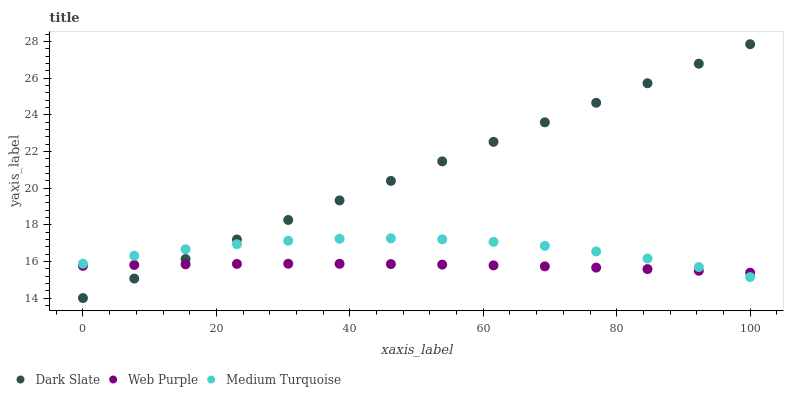Does Web Purple have the minimum area under the curve?
Answer yes or no. Yes. Does Dark Slate have the maximum area under the curve?
Answer yes or no. Yes. Does Medium Turquoise have the minimum area under the curve?
Answer yes or no. No. Does Medium Turquoise have the maximum area under the curve?
Answer yes or no. No. Is Dark Slate the smoothest?
Answer yes or no. Yes. Is Medium Turquoise the roughest?
Answer yes or no. Yes. Is Web Purple the smoothest?
Answer yes or no. No. Is Web Purple the roughest?
Answer yes or no. No. Does Dark Slate have the lowest value?
Answer yes or no. Yes. Does Medium Turquoise have the lowest value?
Answer yes or no. No. Does Dark Slate have the highest value?
Answer yes or no. Yes. Does Medium Turquoise have the highest value?
Answer yes or no. No. Does Medium Turquoise intersect Dark Slate?
Answer yes or no. Yes. Is Medium Turquoise less than Dark Slate?
Answer yes or no. No. Is Medium Turquoise greater than Dark Slate?
Answer yes or no. No. 